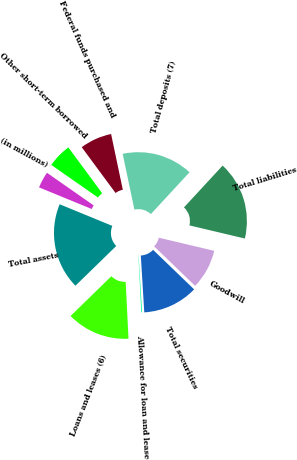Convert chart. <chart><loc_0><loc_0><loc_500><loc_500><pie_chart><fcel>(in millions)<fcel>Total assets<fcel>Loans and leases (6)<fcel>Allowance for loan and lease<fcel>Total securities<fcel>Goodwill<fcel>Total liabilities<fcel>Total deposits (7)<fcel>Federal funds purchased and<fcel>Other short-term borrowed<nl><fcel>3.5%<fcel>18.5%<fcel>13.5%<fcel>0.17%<fcel>11.83%<fcel>8.5%<fcel>16.83%<fcel>15.17%<fcel>6.83%<fcel>5.17%<nl></chart> 